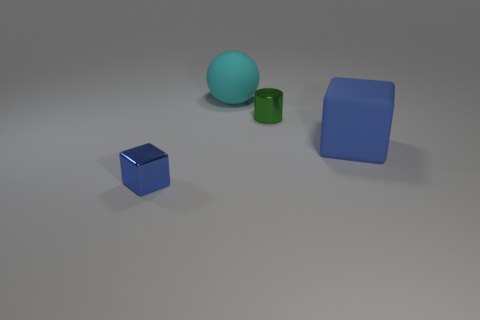Are there fewer matte objects that are in front of the matte ball than small green metallic things that are to the left of the small cylinder?
Keep it short and to the point. No. What number of things are blocks that are behind the small metallic block or small purple balls?
Your answer should be compact. 1. There is a cyan ball; is its size the same as the blue cube right of the cyan rubber thing?
Your answer should be very brief. Yes. There is another blue object that is the same shape as the big blue rubber object; what is its size?
Make the answer very short. Small. There is a shiny thing that is to the left of the rubber thing behind the big rubber cube; how many cyan balls are in front of it?
Offer a terse response. 0. What number of cylinders are either big matte objects or small blue objects?
Your answer should be very brief. 0. What color is the tiny metallic object to the left of the small object behind the blue block that is on the left side of the big cyan object?
Your response must be concise. Blue. Is there anything else that is the same shape as the small green object?
Your response must be concise. No. The big thing that is the same shape as the small blue thing is what color?
Offer a terse response. Blue. There is a small cylinder that is made of the same material as the tiny block; what is its color?
Offer a very short reply. Green. 